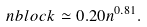Convert formula to latex. <formula><loc_0><loc_0><loc_500><loc_500>\ n b l o c k \simeq 0 . 2 0 n ^ { 0 . 8 1 } .</formula> 